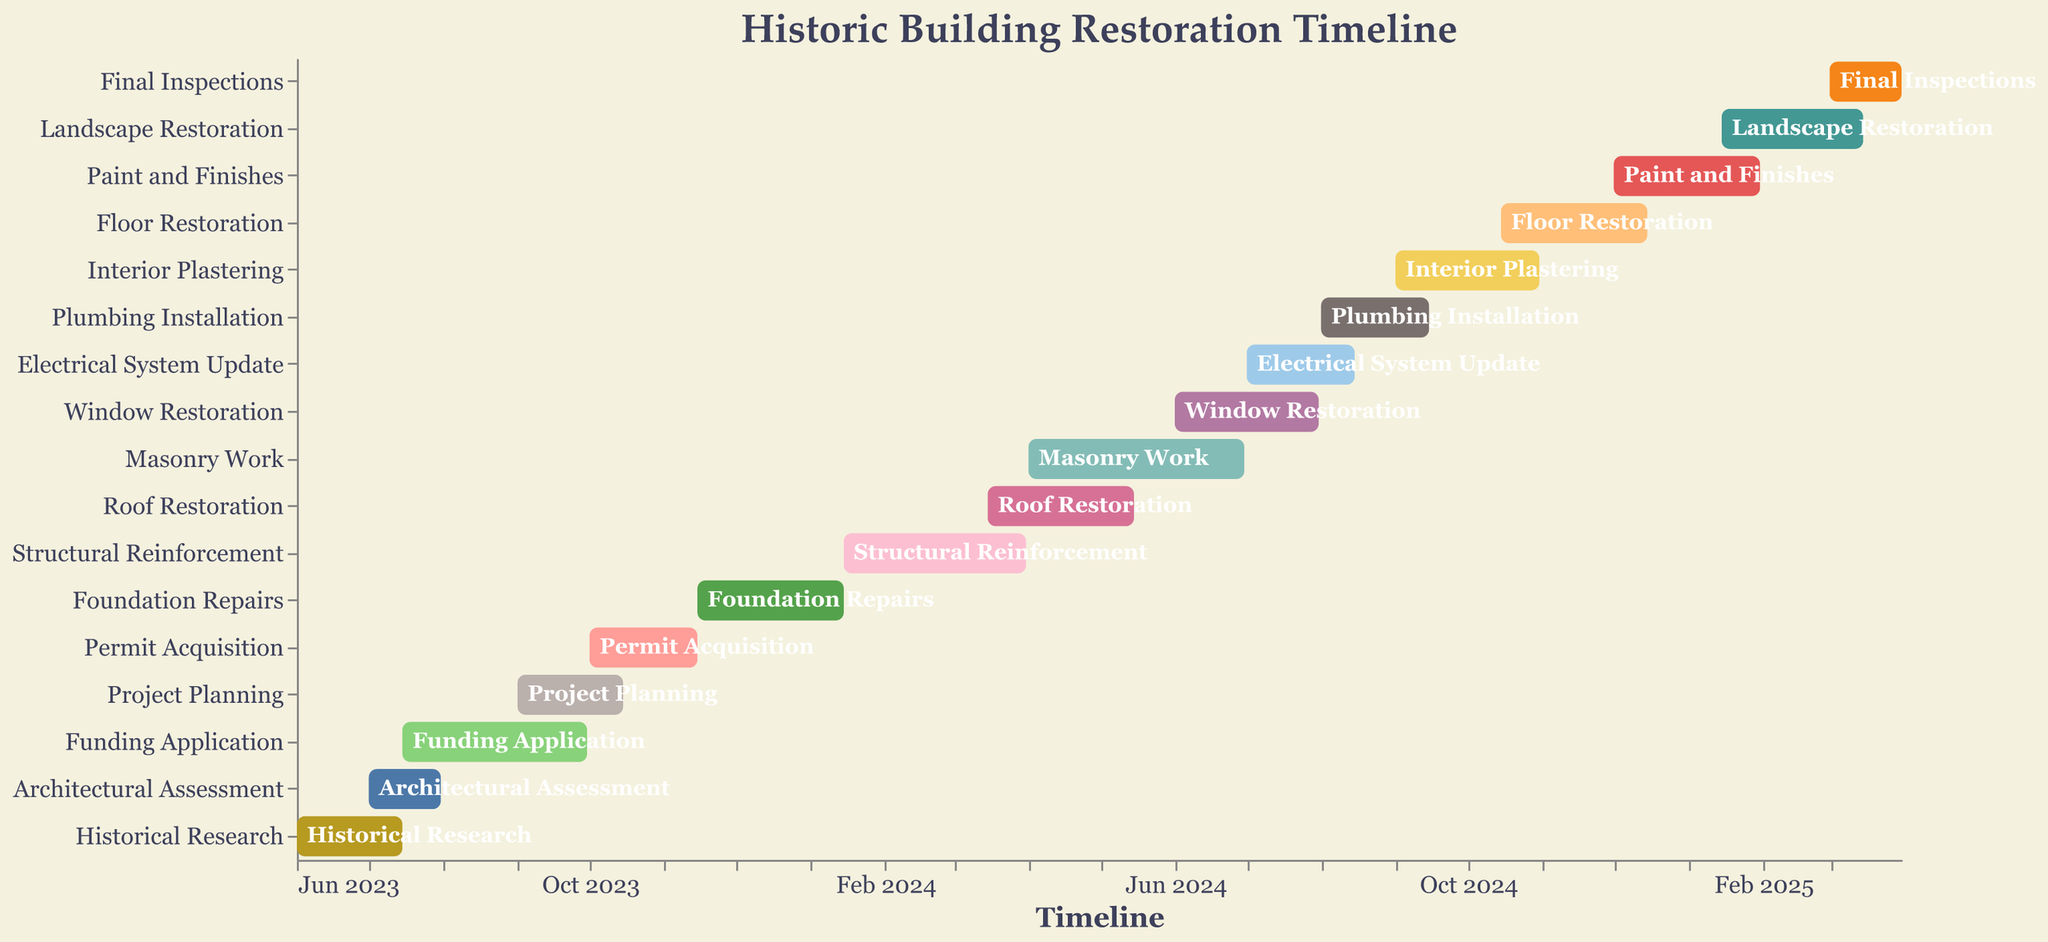How long does the Historical Research phase last? Look at the "Historical Research" bar and check the start and end dates. It starts on June 1, 2023, and ends on July 15, 2023. Calculate the difference.
Answer: 1.5 months Which phases happen fully or partially in August 2024? The phases to consider are those where the bar intersects with August 2024. We see "Window Restoration" (ends July 31, 2024), "Electrical System Update" (July 1 - August 15), and "Plumbing Installation" (August 1 - Sep 15).
Answer: Window Restoration, Electrical System Update, Plumbing Installation What phase is the longest in duration? By visually comparing the lengths of the bars, we see that "Masonry Work" (Apr 1 - Jun 30, 2024) spans the most extended period.
Answer: Masonry Work Which phase directly follows the Project Planning phase? Locate the "Project Planning" bar and identify the next bar starting immediately after its end date, which is "Permit Acquisition" starting on October 1, 2023.
Answer: Permit Acquisition How many phases start in the year 2024? Count the number of bars with start dates in 2024. These are "Foundation Repairs," "Structural Reinforcement," "Roof Restoration," "Masonry Work," "Window Restoration," "Electrical System Update," "Plumbing Installation," "Interior Plastering," "Floor Restoration," and "Paint and Finishes."
Answer: 10 phases Which phase is overlapping with the "Permit Acquisition" phase? Look at the bars that share some time with "Permit Acquisition" (Oct 1 - Nov 15, 2023). The overlapping bar is "Foundation Repairs," which starts on November 15, 2023.
Answer: Foundation Repairs When does the Landscape Restoration phase start and end? Look at the bar labeled "Landscape Restoration" to find its dates. It starts on January 15, 2025, and ends on March 15, 2025.
Answer: January 15, 2025, to March 15, 2025 Which tasks are completed in the year 2023? Identify the bars that end within 2023. These include "Historical Research," "Architectural Assessment," "Funding Application," "Project Planning," and "Permit Acquisition."
Answer: Historical Research, Architectural Assessment, Funding Application, Project Planning, Permit Acquisition What is the total duration of the Structural Reinforcement phase? Measure the start and end date of the "Structural Reinforcement" phase, from January 15, 2024, to March 31, 2024. That is 2.5 months.
Answer: 2.5 months 